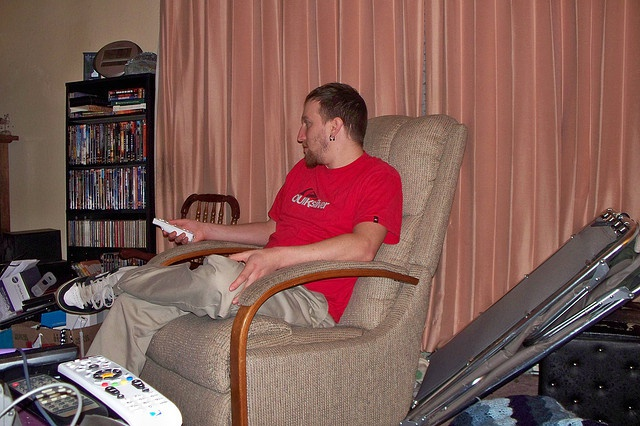Describe the objects in this image and their specific colors. I can see chair in maroon, gray, and darkgray tones, people in maroon, brown, darkgray, and gray tones, remote in maroon, white, darkgray, black, and gray tones, book in maroon, black, and gray tones, and remote in maroon, gray, darkgray, black, and lightgray tones in this image. 